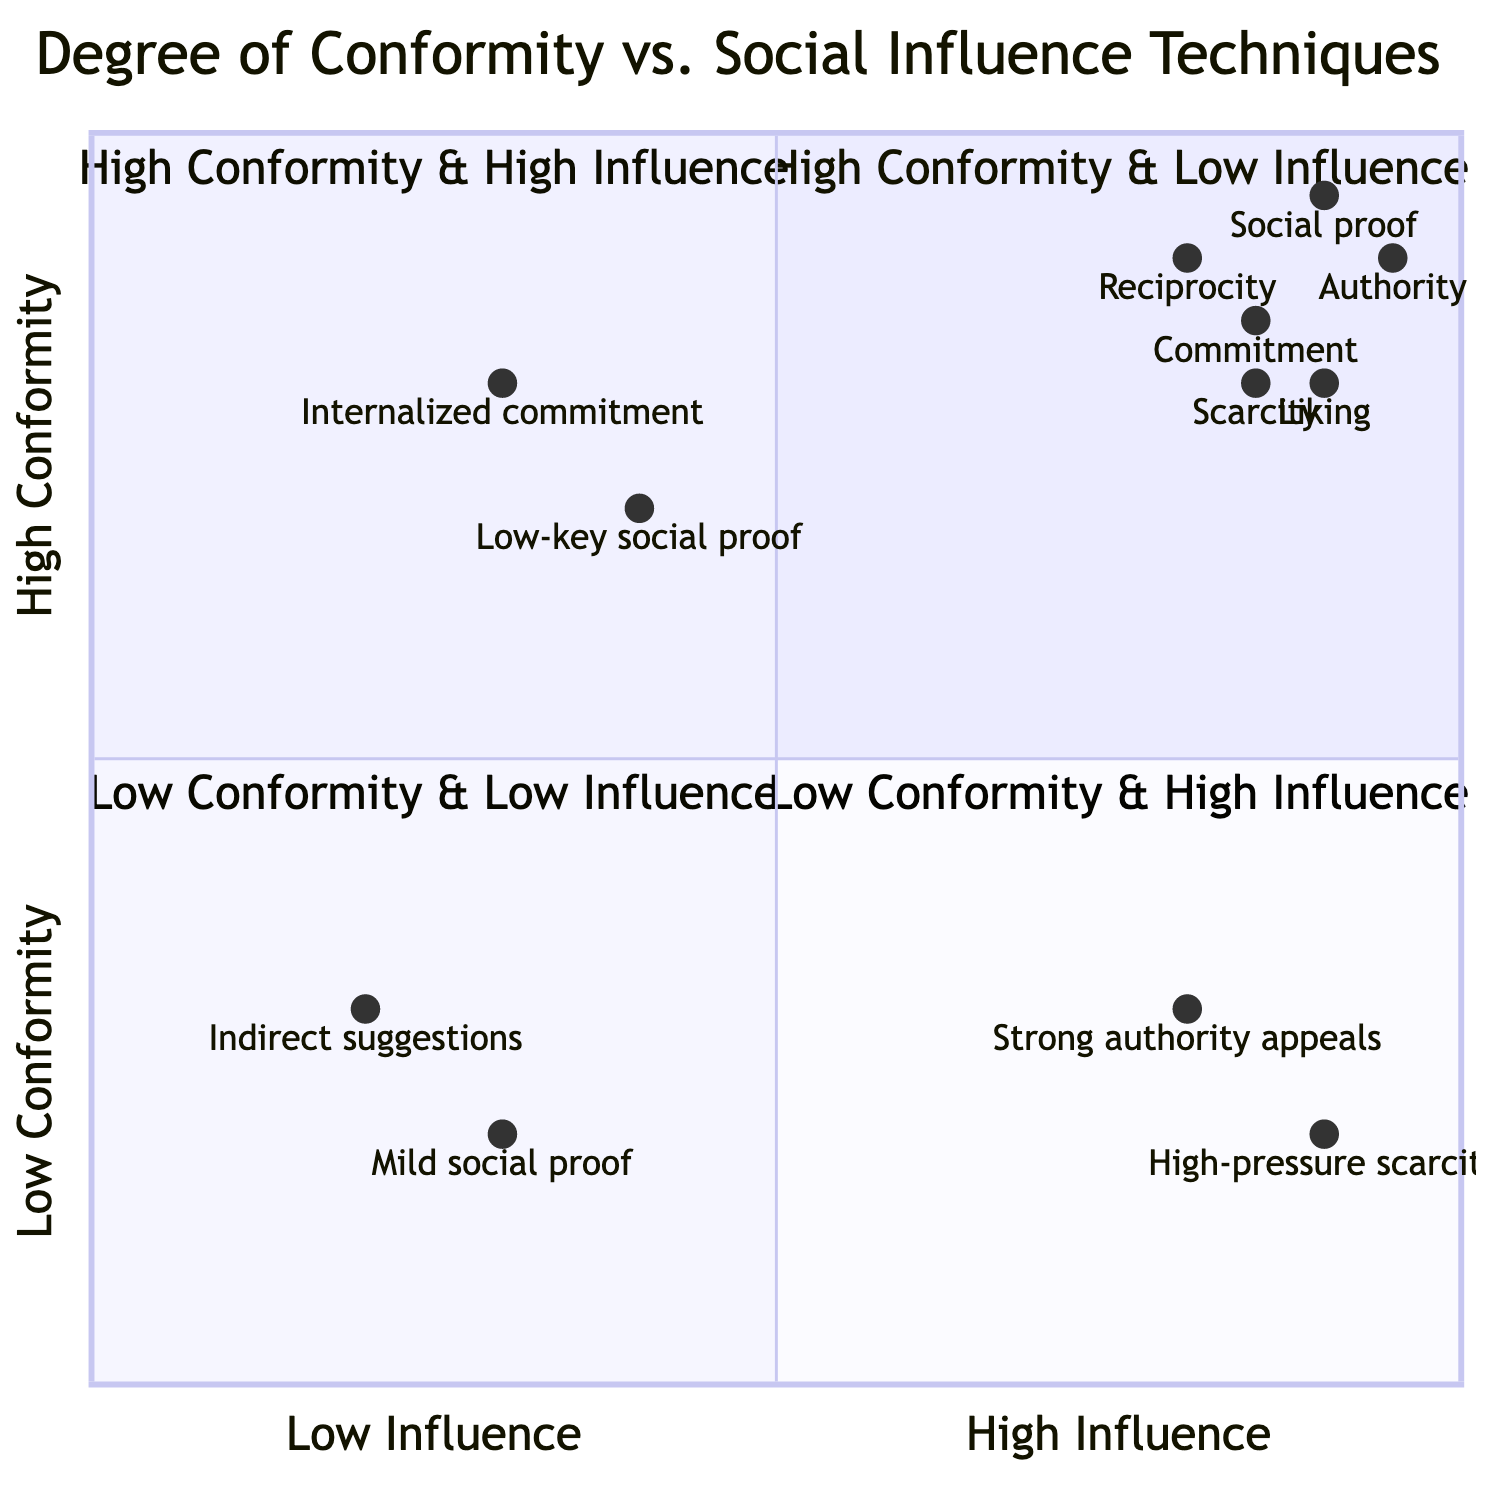What are the characteristics of the "High Conformity & High Influence" quadrant? In the "High Conformity & High Influence" quadrant, the key characteristics include marked adherence to social norms, high susceptibility to social influence, and conformity often driven by strong external social factors.
Answer: Marked adherence to social norms and high susceptibility to social influence What technique is associated with the "Low Conformity & High Influence" quadrant? The "Low Conformity & High Influence" quadrant is characterized by techniques like strong authority appeals and high-pressure scarcity tactics, though individuals may resist these influences.
Answer: Strong authority appeals What is the example given for "Low Conformity & Low Influence"? The example for this quadrant includes individualistic behaviors in personal hobbies or niche interests, representing a lack of both social influence and conformity.
Answer: Individualistic behavior in personal hobbies Which social influence technique scores the highest in "High Conformity & High Influence"? Among the techniques listed in this quadrant, authority has the highest score, indicating a strong influence from authority figures.
Answer: Authority How many techniques are listed in the "High Conformity & High Influence" quadrant? The "High Conformity & High Influence" quadrant lists a total of six techniques, reflecting the various social influence mechanisms at play.
Answer: Six techniques Which quadrant features individuals with minimal influence exerted or perceived? The "Low Conformity & Low Influence" quadrant describes a situation where individuals experience minimal influence from social groups or figures, reflecting high personal autonomy.
Answer: Low Conformity & Low Influence What is the primary characteristic of individuals in the "High Conformity & Low Influence" quadrant? Individuals in the "High Conformity & Low Influence" quadrant adhere to norms despite minimal external pressure, often due to internalized norms or strong personal values.
Answer: High adherence to norms with minimal external pressure What is the score for "commitment" in the "High Conformity & High Influence" quadrant? The score for commitment in this quadrant is 0.85, suggesting a strong tendency to stay committed to decisions made, often influenced by social norms.
Answer: 0.85 